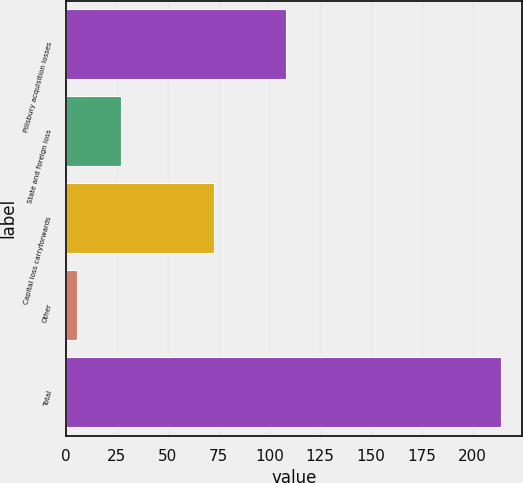<chart> <loc_0><loc_0><loc_500><loc_500><bar_chart><fcel>Pillsbury acquisition losses<fcel>State and foreign loss<fcel>Capital loss carryforwards<fcel>Other<fcel>Total<nl><fcel>108.2<fcel>27<fcel>73<fcel>5.5<fcel>213.7<nl></chart> 